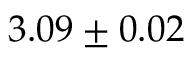<formula> <loc_0><loc_0><loc_500><loc_500>3 . 0 9 \pm 0 . 0 2</formula> 